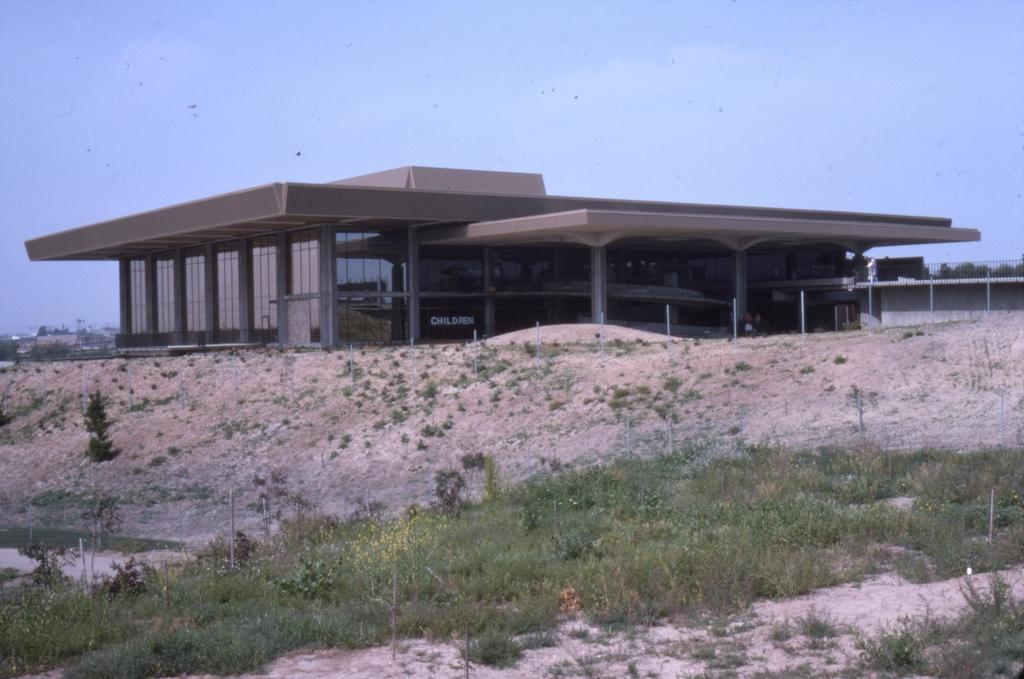What type of structure is located in the center of the image? There is a flat in the center of the image. What type of landscape is visible at the bottom side of the image? There is grassland at the bottom side of the image. How many beads can be seen scattered on the grassland in the image? There are no beads present in the image; it features a flat and grassland. What type of creature is shown interacting with the geese on the grassland in the image? There are no geese or creatures depicted on the grassland in the image. 